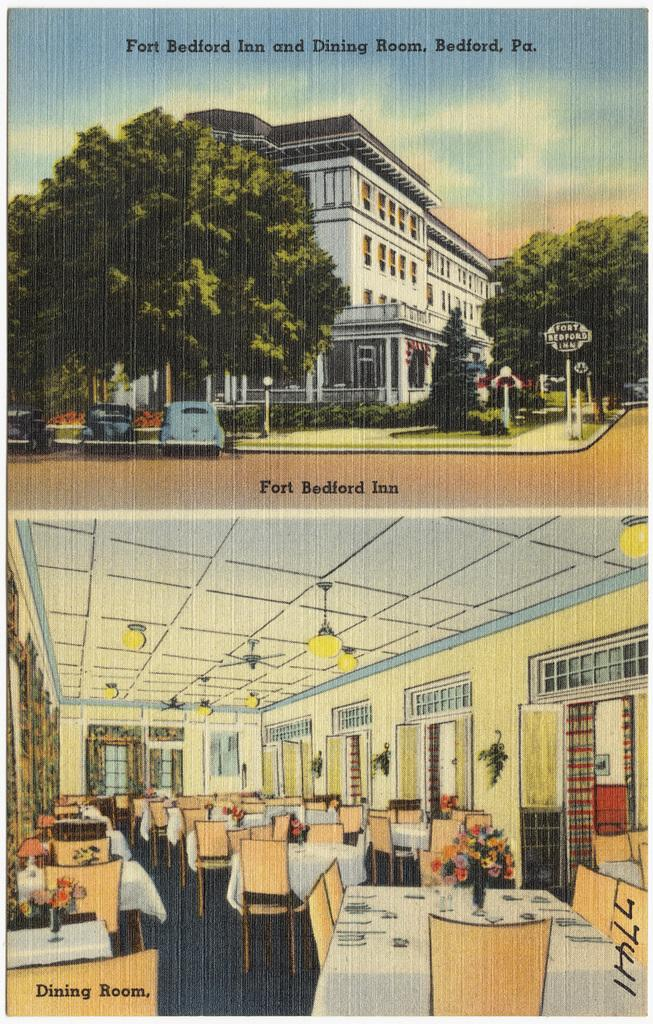Provide a one-sentence caption for the provided image. An old ad for the Fort Bedford Inn that looks drawn. 